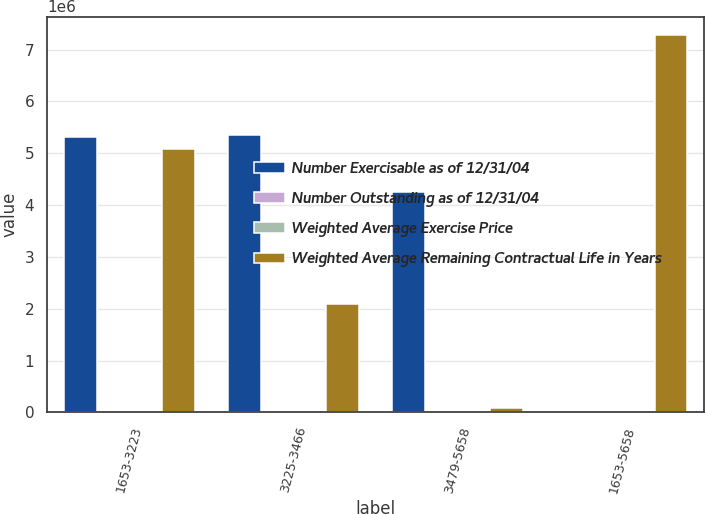<chart> <loc_0><loc_0><loc_500><loc_500><stacked_bar_chart><ecel><fcel>1653-3223<fcel>3225-3466<fcel>3479-5658<fcel>1653-5658<nl><fcel>Number Exercisable as of 12/31/04<fcel>5.30443e+06<fcel>5.34453e+06<fcel>4.26058e+06<fcel>40.96<nl><fcel>Number Outstanding as of 12/31/04<fcel>4.1<fcel>7.4<fcel>9.2<fcel>6.7<nl><fcel>Weighted Average Exercise Price<fcel>25.83<fcel>33.26<fcel>40.96<fcel>32.82<nl><fcel>Weighted Average Remaining Contractual Life in Years<fcel>5.081e+06<fcel>2.09943e+06<fcel>92450<fcel>7.27288e+06<nl></chart> 